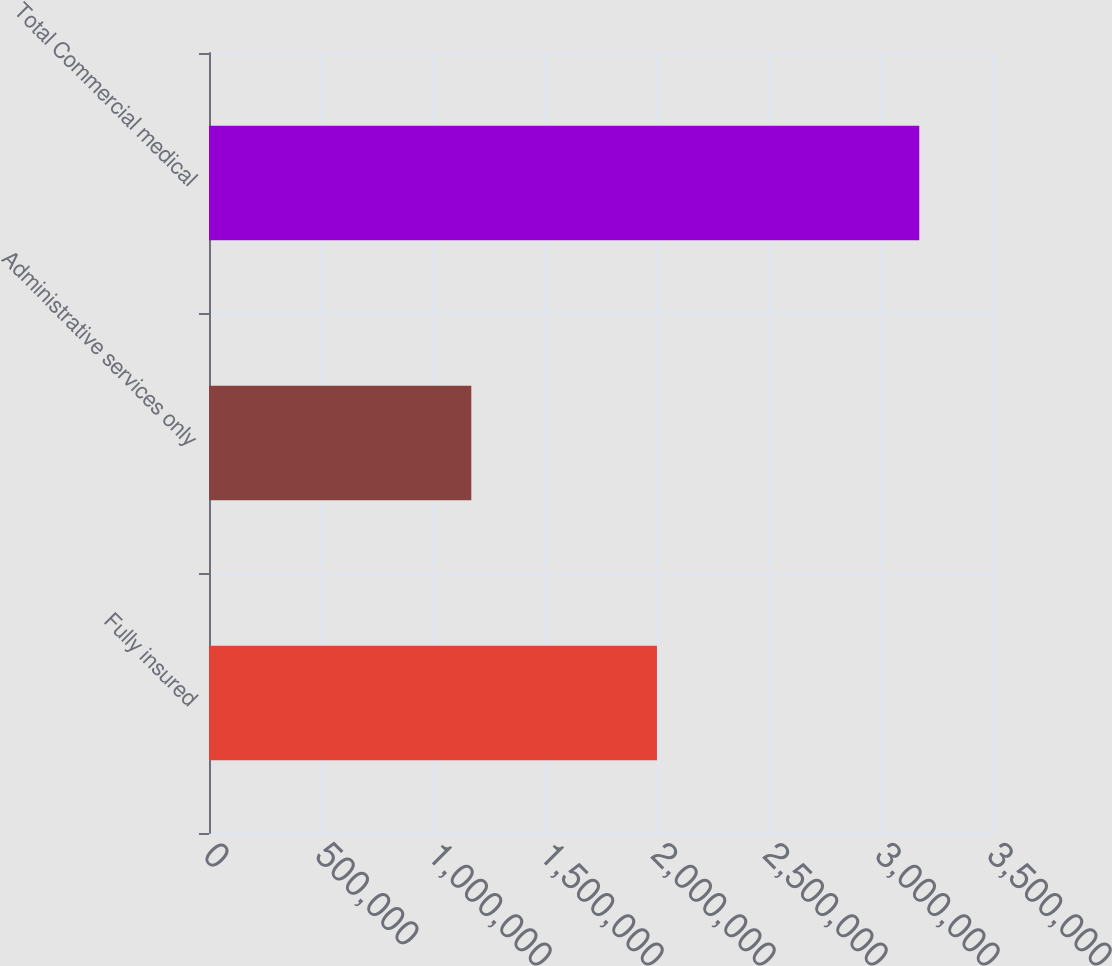Convert chart. <chart><loc_0><loc_0><loc_500><loc_500><bar_chart><fcel>Fully insured<fcel>Administrative services only<fcel>Total Commercial medical<nl><fcel>1.9998e+06<fcel>1.171e+06<fcel>3.1708e+06<nl></chart> 